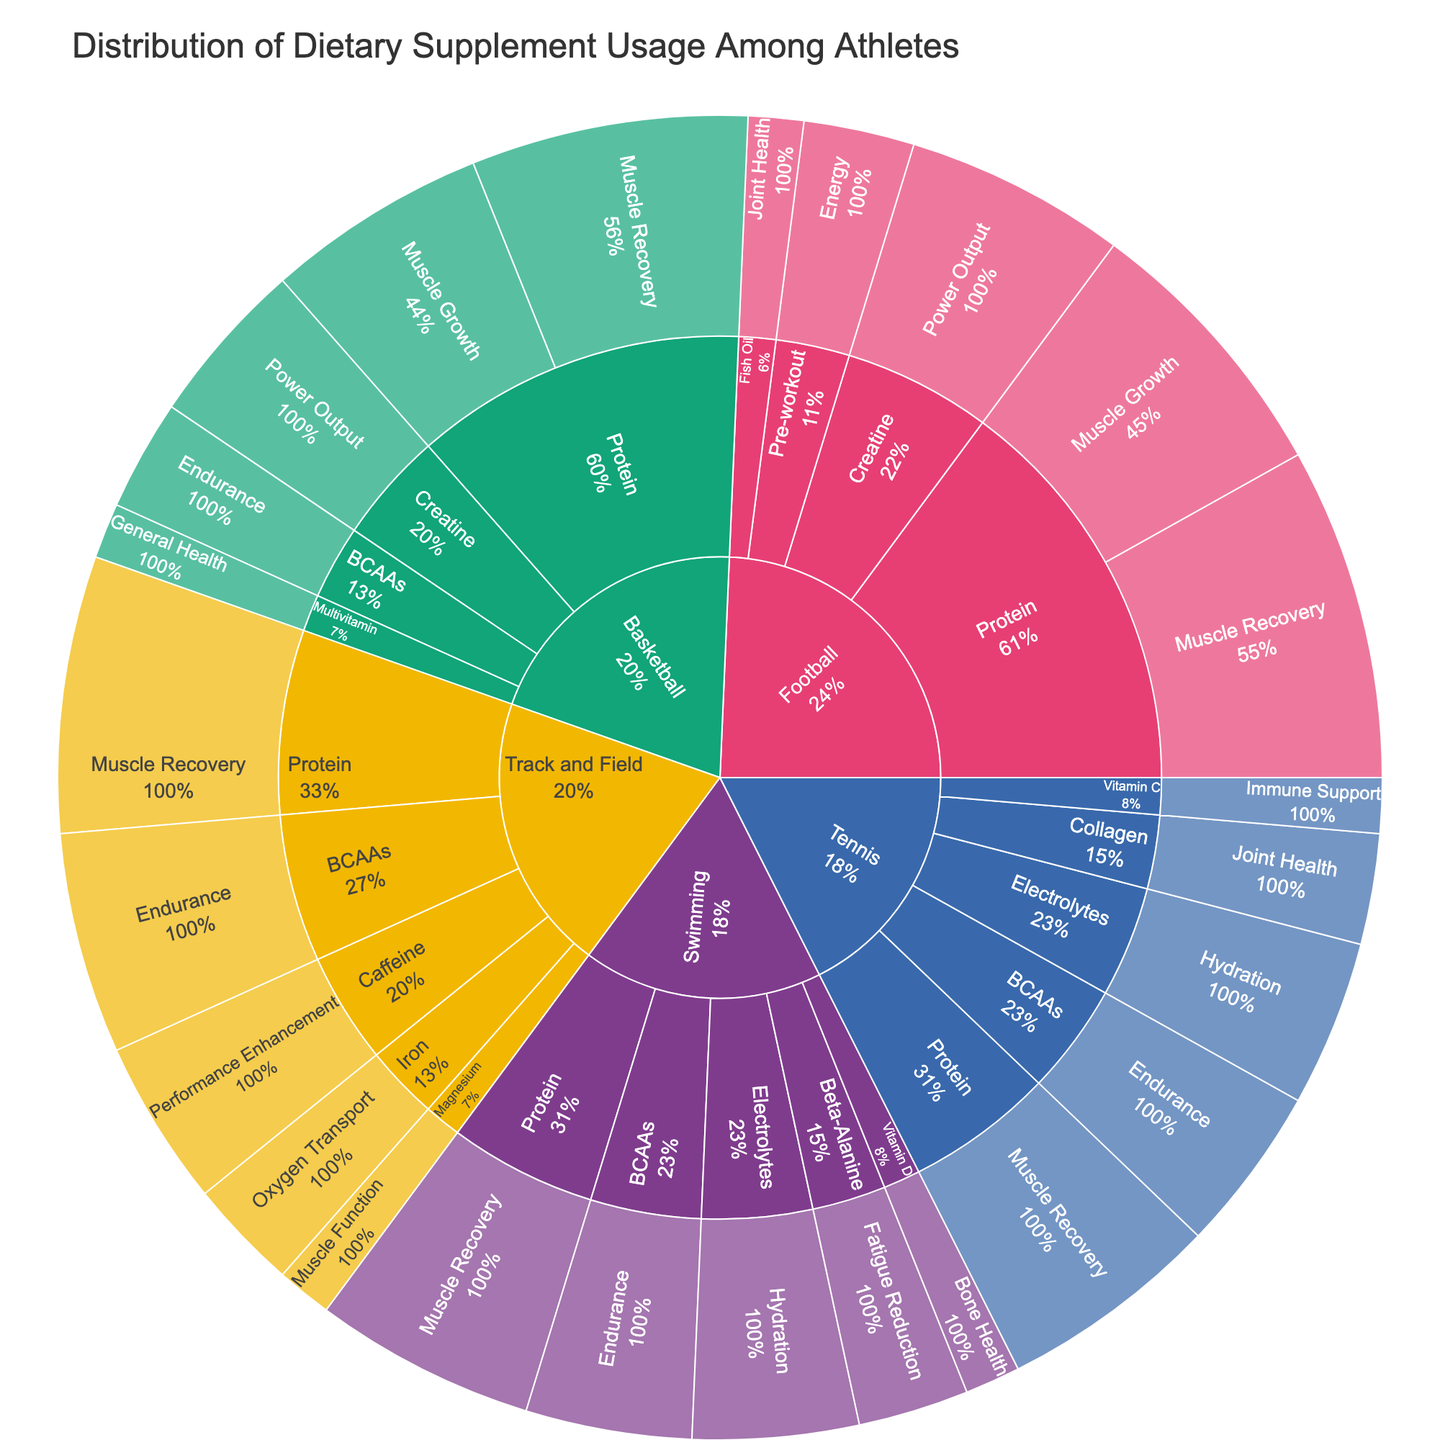What's the title of the plot? The title of the plot is displayed at the top of the figure in a larger font size. This information is usually easy to locate and read.
Answer: Distribution of Dietary Supplement Usage Among Athletes Which sport uses Protein supplements most for Muscle Growth? To answer this, find the "Protein" supplement type and then locate the "Muscle Growth" benefit within the sunburst plot. Check which sport has the highest percentage for this benefit.
Answer: Football What is the total percentage of Protein usage for Muscle Recovery among all sports? Sum up the percentages for "Protein" used for "Muscle Recovery" across all sports: Basketball (25%), Football (30%), Swimming (20%), Track and Field (25%), and Tennis (20%). The total is 25 + 30 + 20 + 25 + 20.
Answer: 120% Which supplement type is used for "Endurance" in Track and Field and what is the percentage? Look for the Track and Field sport category and find the specific supplement type used for "Endurance" within the sunburst plot. Note the percentage value associated with it.
Answer: BCAAs, 20% Compare the percentage of Fish Oil used for Joint Health in Football versus Collagen used for Joint Health in Tennis. Which is higher? Identify and compare the percentage values for Fish Oil used for Joint Health in Football (5%) and Collagen used for Joint Health in Tennis (10%).
Answer: Collagen in Tennis What is the least common intended benefit for supplements used in Swimming? Look at the different intended benefits listed under Swimming and identify the one with the smallest percentage.
Answer: Bone Health How does the usage percentage of Creatine for Power Output compare between Basketball and Football? Find the percentage values for Creatine used for Power Output in both Basketball (15%) and Football (20%). Compare which one is higher.
Answer: Football's usage is higher What percentage of Tennis players use supplements for Hydration, and which supplement type do they primarily use for this benefit? Locate the "Hydration" category under Tennis within the sunburst plot, and note down the supplement type and the associated percentage.
Answer: Electrolytes, 15% Identify the sport with the highest diversity in supplement types and explain how you determined it. Examine each sport's category and count the number of distinct supplement types associated with each. The sport with the highest count has the greatest diversity.
Answer: Basketball, with 5 types What is the most common intended benefit for supplements in Tennis, and what is its percentage? Look at Tennis and identify the intended benefit with the highest percentage. Refer to the respective segment in the plot.
Answer: Muscle Recovery, 20% 